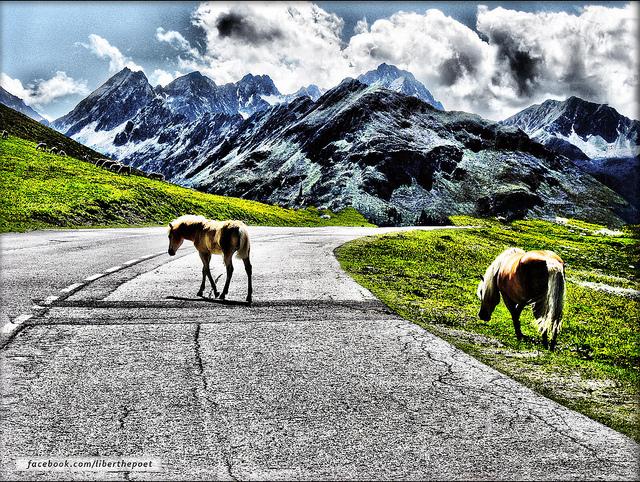Are these horses feral?
Concise answer only. Yes. How many horses are there?
Give a very brief answer. 2. Are there mountains in the photo?
Be succinct. Yes. 